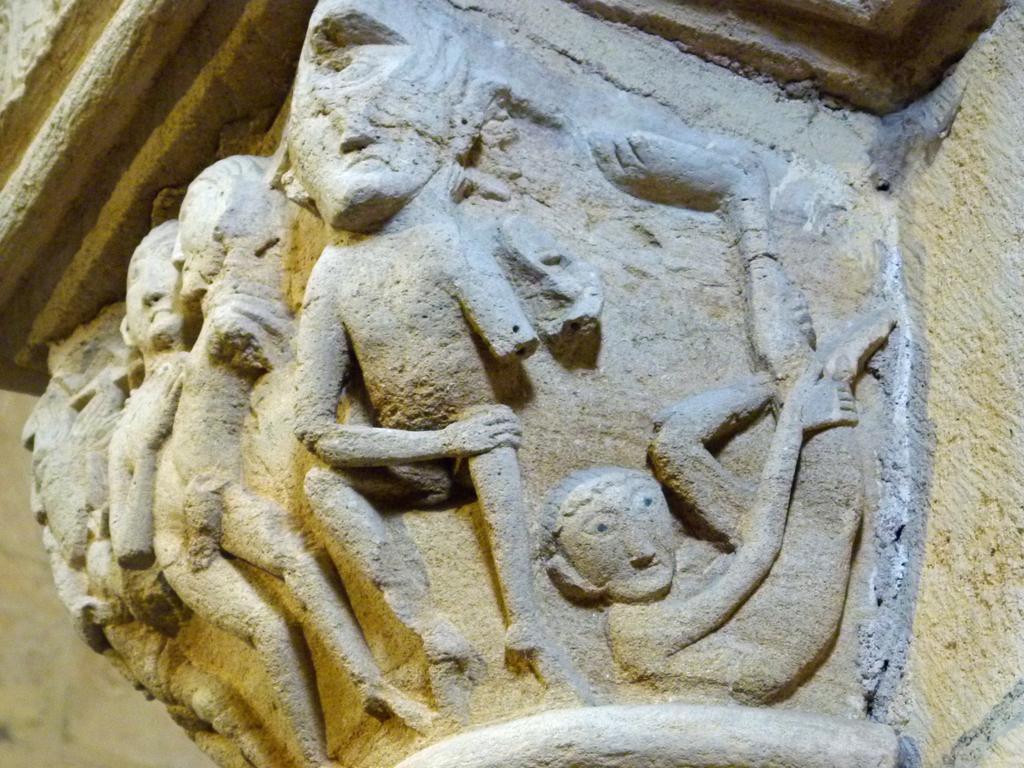What is depicted on the wall in the image? There are sculptures on the wall in the image. What type of chalk is being used to draw on the sculptures in the image? There is no chalk or drawing present in the image; it only features sculptures on the wall. 